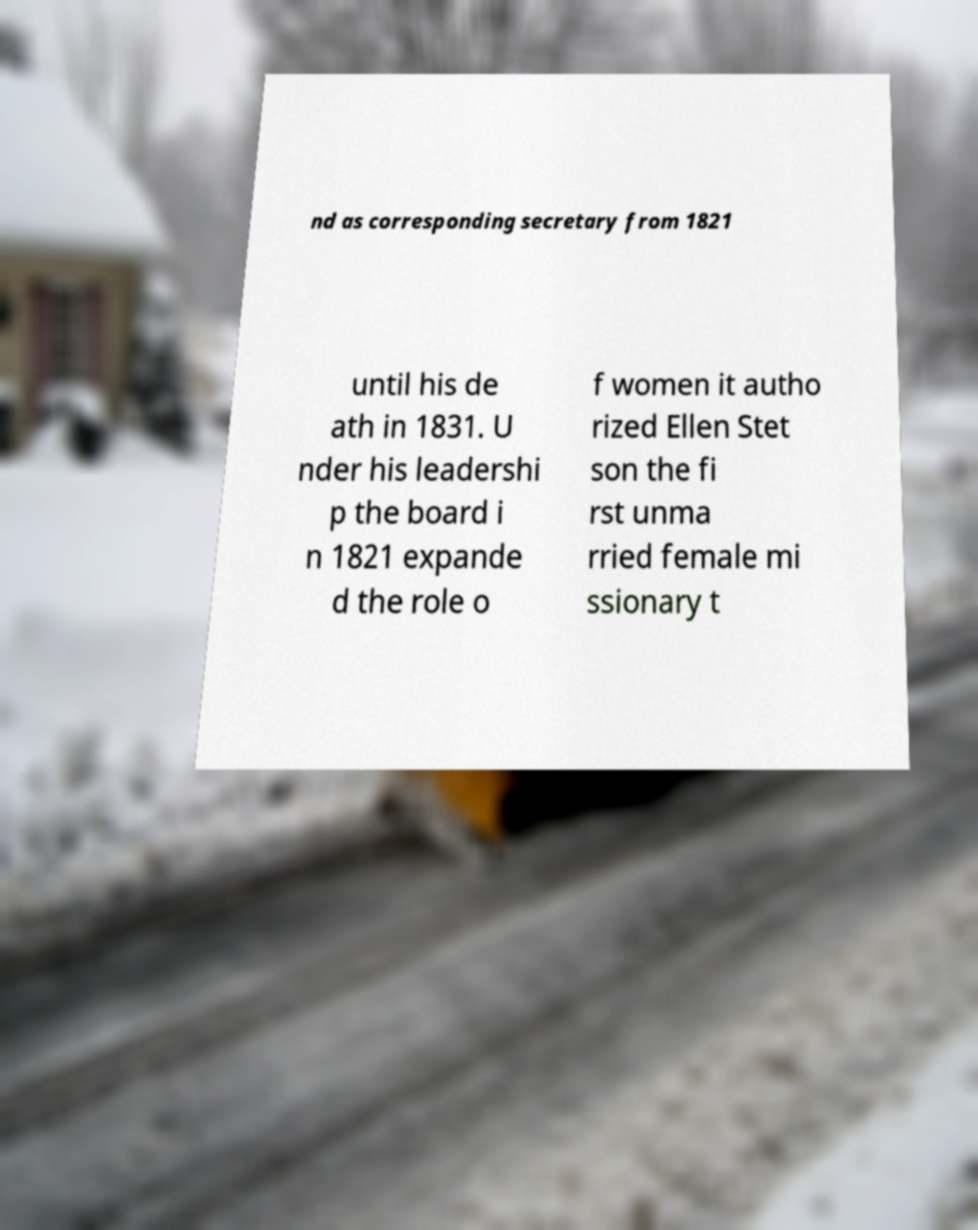There's text embedded in this image that I need extracted. Can you transcribe it verbatim? nd as corresponding secretary from 1821 until his de ath in 1831. U nder his leadershi p the board i n 1821 expande d the role o f women it autho rized Ellen Stet son the fi rst unma rried female mi ssionary t 